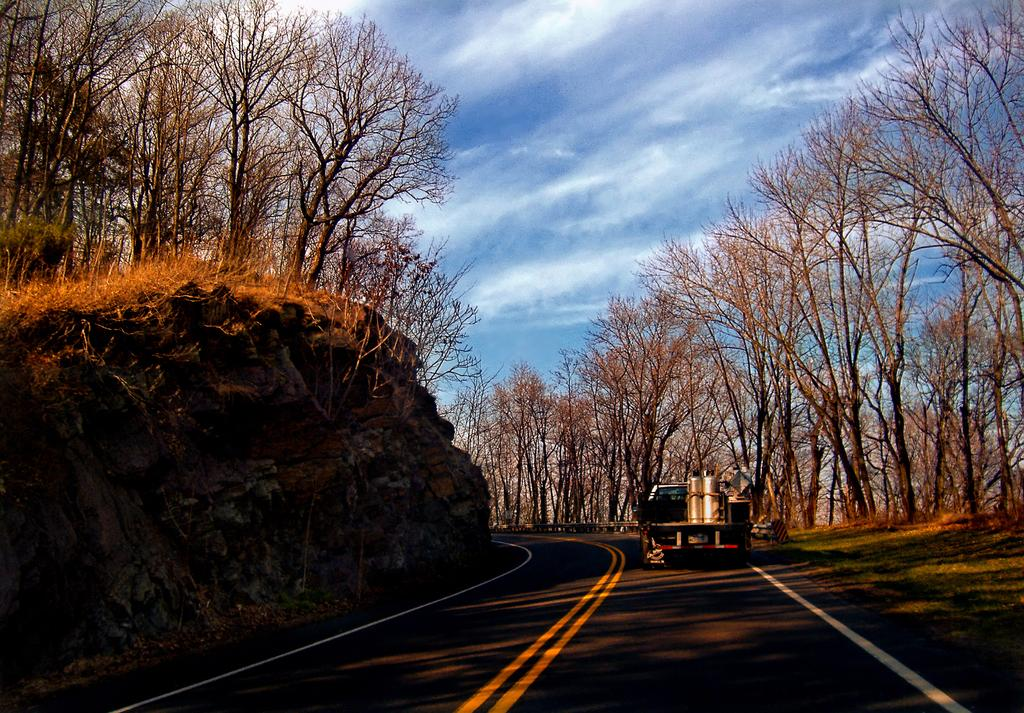What is the main feature of the image? There is a road in the image. What is happening on the road? A vehicle is moving on the road. What can be seen on both sides of the road? There are trees on either side of the road. What is visible at the top of the image? The sky is visible at the top of the image. How would you describe the weather based on the sky? The sky appears to be sunny. Can you tell me the name of the father of the representative in the image? There is no father or representative present in the image. What type of sound can be heard coming from the vehicle in the image? The image does not provide any information about the sound produced by the vehicle. 